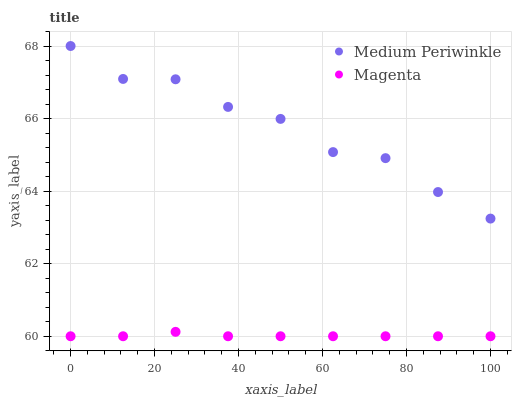Does Magenta have the minimum area under the curve?
Answer yes or no. Yes. Does Medium Periwinkle have the maximum area under the curve?
Answer yes or no. Yes. Does Medium Periwinkle have the minimum area under the curve?
Answer yes or no. No. Is Magenta the smoothest?
Answer yes or no. Yes. Is Medium Periwinkle the roughest?
Answer yes or no. Yes. Is Medium Periwinkle the smoothest?
Answer yes or no. No. Does Magenta have the lowest value?
Answer yes or no. Yes. Does Medium Periwinkle have the lowest value?
Answer yes or no. No. Does Medium Periwinkle have the highest value?
Answer yes or no. Yes. Is Magenta less than Medium Periwinkle?
Answer yes or no. Yes. Is Medium Periwinkle greater than Magenta?
Answer yes or no. Yes. Does Magenta intersect Medium Periwinkle?
Answer yes or no. No. 